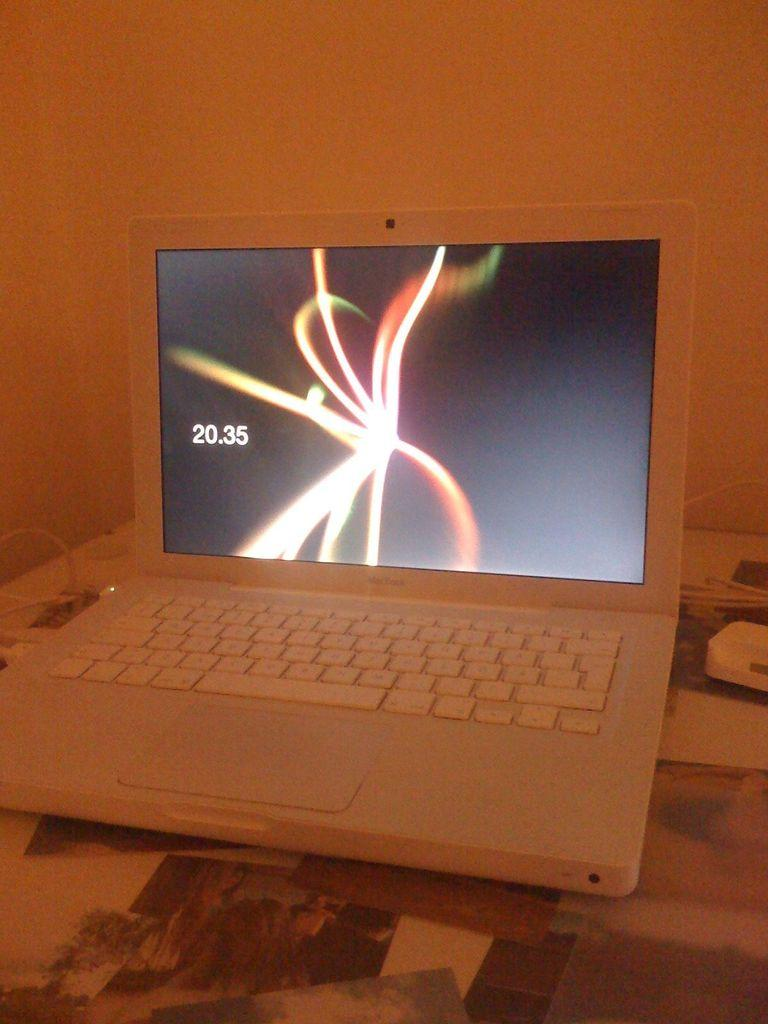Provide a one-sentence caption for the provided image. A white laptop with some sort of light display on the screen next to the number 20.35. 